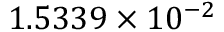<formula> <loc_0><loc_0><loc_500><loc_500>1 . 5 3 3 9 \times 1 0 ^ { - 2 }</formula> 